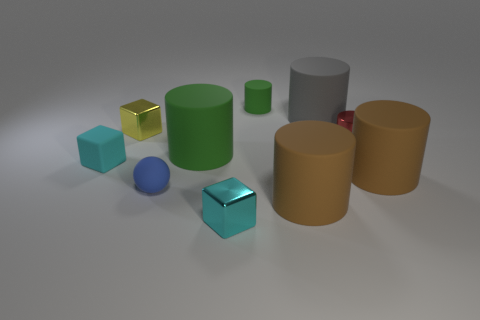Subtract all red cylinders. How many cylinders are left? 5 Subtract all small shiny blocks. How many blocks are left? 1 Subtract 1 cylinders. How many cylinders are left? 5 Subtract all cyan cylinders. Subtract all gray blocks. How many cylinders are left? 6 Subtract all cylinders. How many objects are left? 4 Add 1 yellow metal things. How many yellow metal things exist? 2 Subtract 0 red spheres. How many objects are left? 10 Subtract all big yellow metallic spheres. Subtract all small cyan matte things. How many objects are left? 9 Add 1 small metallic blocks. How many small metallic blocks are left? 3 